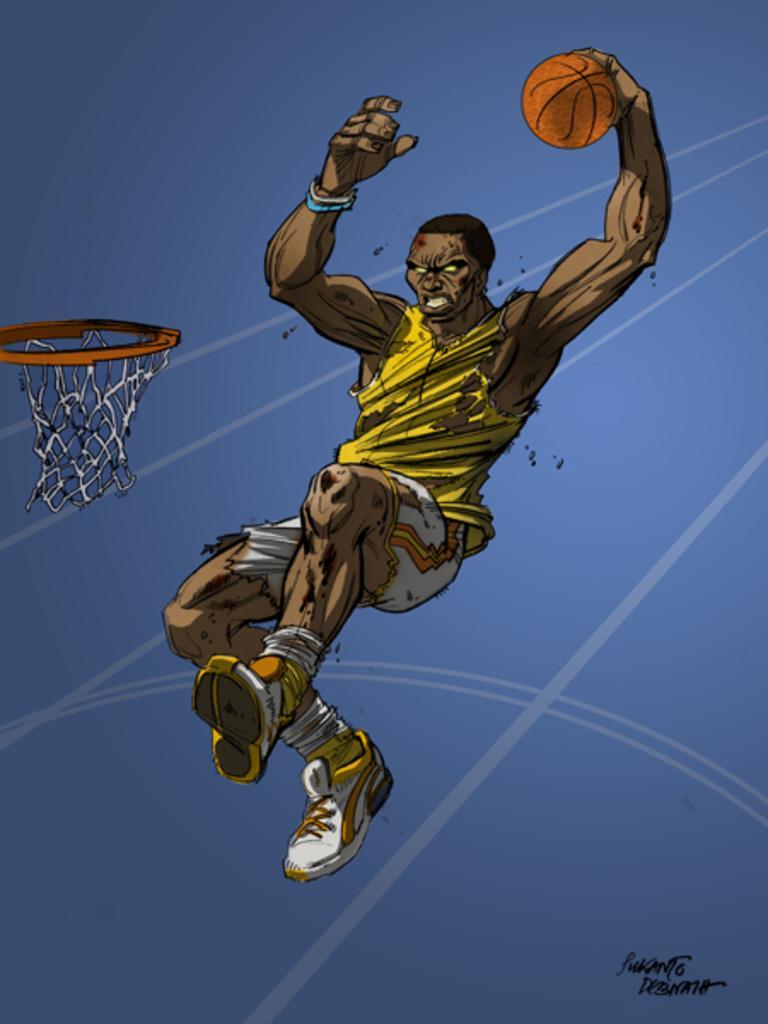Can you describe this image briefly? In this image we can see there is an art of a person playing basketball. 